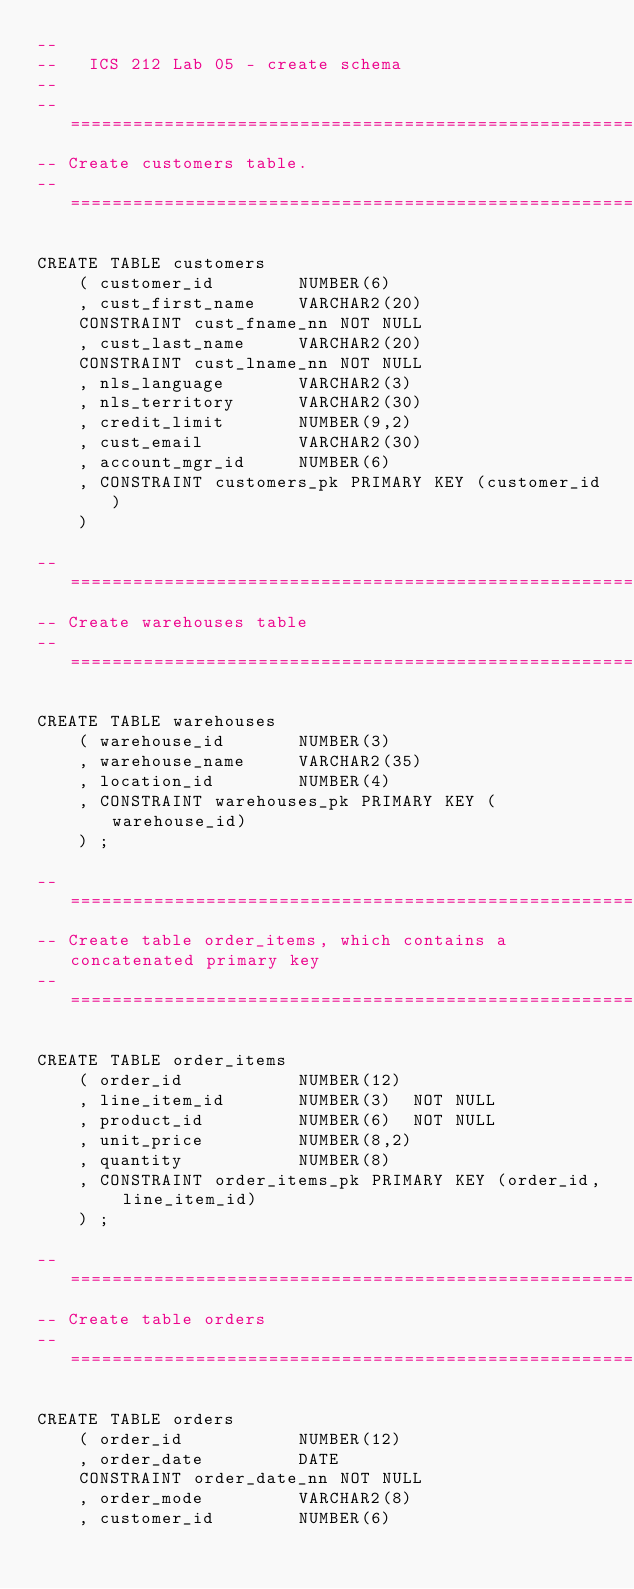Convert code to text. <code><loc_0><loc_0><loc_500><loc_500><_SQL_>--
--   ICS 212 Lab 05 - create schema
-- 
-- ===========================================================================
-- Create customers table.
-- ===========================================================================

CREATE TABLE customers
    ( customer_id        NUMBER(6)     
    , cust_first_name    VARCHAR2(20) 
    CONSTRAINT cust_fname_nn NOT NULL
    , cust_last_name     VARCHAR2(20) 
    CONSTRAINT cust_lname_nn NOT NULL
    , nls_language       VARCHAR2(3)
    , nls_territory      VARCHAR2(30)
    , credit_limit       NUMBER(9,2)
    , cust_email         VARCHAR2(30)
    , account_mgr_id     NUMBER(6)
    , CONSTRAINT customers_pk PRIMARY KEY (customer_id)
    )

-- ===========================================================================
-- Create warehouses table
-- ===========================================================================

CREATE TABLE warehouses
    ( warehouse_id       NUMBER(3) 
    , warehouse_name     VARCHAR2(35)
    , location_id        NUMBER(4)
    , CONSTRAINT warehouses_pk PRIMARY KEY (warehouse_id)
    ) ;

-- ===========================================================================
-- Create table order_items, which contains a concatenated primary key
-- ===========================================================================
	
CREATE TABLE order_items
    ( order_id           NUMBER(12) 
    , line_item_id       NUMBER(3)  NOT NULL
    , product_id         NUMBER(6)  NOT NULL
    , unit_price         NUMBER(8,2)
    , quantity           NUMBER(8)
    , CONSTRAINT order_items_pk PRIMARY KEY (order_id, line_item_id)
    ) ;

-- ===========================================================================
-- Create table orders
-- ===========================================================================

CREATE TABLE orders
    ( order_id           NUMBER(12)
    , order_date         DATE
    CONSTRAINT order_date_nn NOT NULL
    , order_mode         VARCHAR2(8)
    , customer_id        NUMBER(6) </code> 